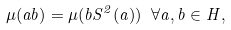Convert formula to latex. <formula><loc_0><loc_0><loc_500><loc_500>\mu ( a b ) = \mu ( b S ^ { 2 } ( a ) ) \ \forall a , b \in H ,</formula> 